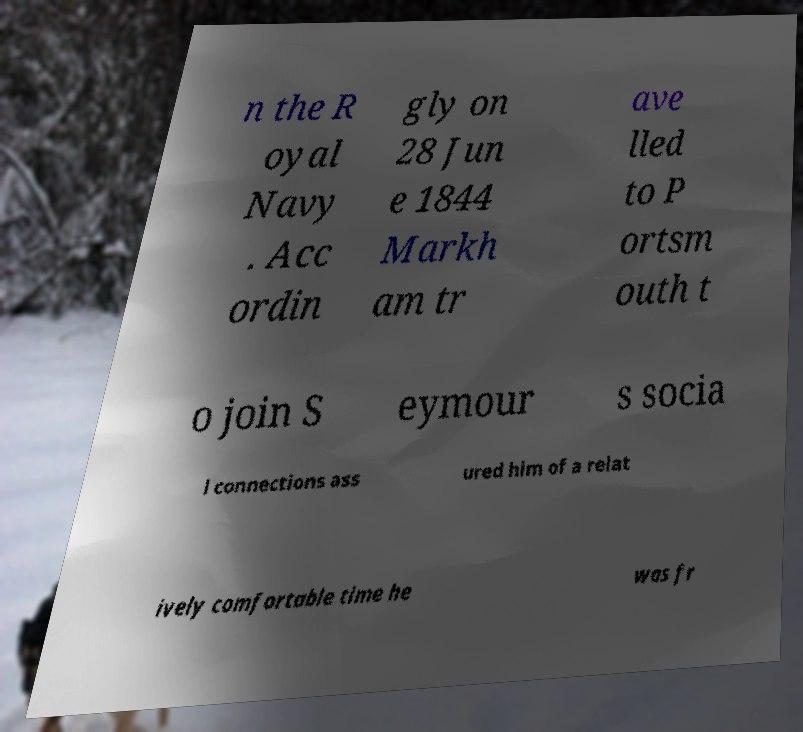There's text embedded in this image that I need extracted. Can you transcribe it verbatim? n the R oyal Navy . Acc ordin gly on 28 Jun e 1844 Markh am tr ave lled to P ortsm outh t o join S eymour s socia l connections ass ured him of a relat ively comfortable time he was fr 